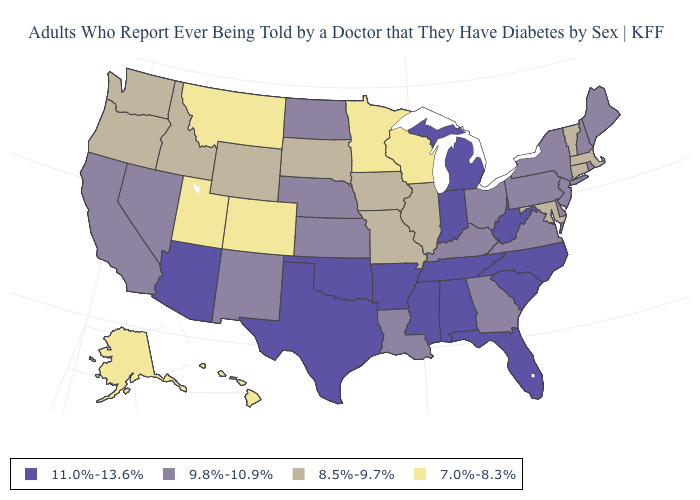What is the lowest value in the West?
Concise answer only. 7.0%-8.3%. How many symbols are there in the legend?
Keep it brief. 4. Which states have the highest value in the USA?
Answer briefly. Alabama, Arizona, Arkansas, Florida, Indiana, Michigan, Mississippi, North Carolina, Oklahoma, South Carolina, Tennessee, Texas, West Virginia. Does the first symbol in the legend represent the smallest category?
Quick response, please. No. What is the value of Missouri?
Write a very short answer. 8.5%-9.7%. Which states have the lowest value in the USA?
Answer briefly. Alaska, Colorado, Hawaii, Minnesota, Montana, Utah, Wisconsin. What is the lowest value in the Northeast?
Write a very short answer. 8.5%-9.7%. Is the legend a continuous bar?
Write a very short answer. No. What is the value of New Mexico?
Keep it brief. 9.8%-10.9%. What is the value of Michigan?
Short answer required. 11.0%-13.6%. Does Nebraska have a lower value than California?
Write a very short answer. No. Among the states that border Alabama , does Georgia have the highest value?
Answer briefly. No. What is the value of Ohio?
Keep it brief. 9.8%-10.9%. 